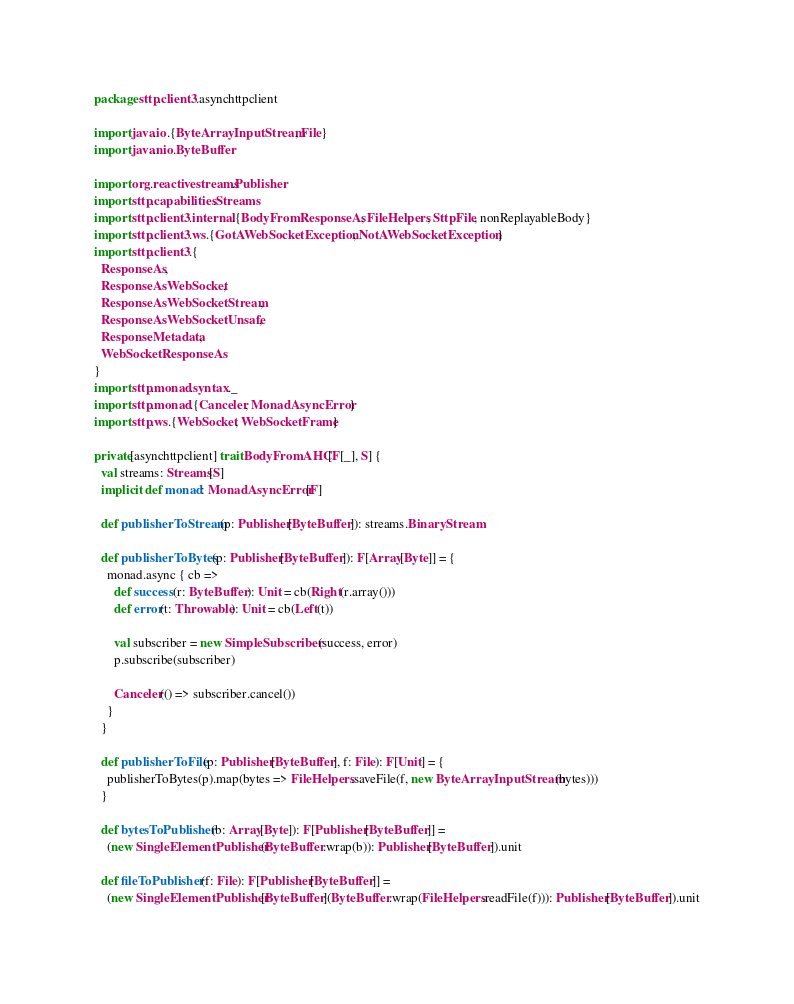Convert code to text. <code><loc_0><loc_0><loc_500><loc_500><_Scala_>package sttp.client3.asynchttpclient

import java.io.{ByteArrayInputStream, File}
import java.nio.ByteBuffer

import org.reactivestreams.Publisher
import sttp.capabilities.Streams
import sttp.client3.internal.{BodyFromResponseAs, FileHelpers, SttpFile, nonReplayableBody}
import sttp.client3.ws.{GotAWebSocketException, NotAWebSocketException}
import sttp.client3.{
  ResponseAs,
  ResponseAsWebSocket,
  ResponseAsWebSocketStream,
  ResponseAsWebSocketUnsafe,
  ResponseMetadata,
  WebSocketResponseAs
}
import sttp.monad.syntax._
import sttp.monad.{Canceler, MonadAsyncError}
import sttp.ws.{WebSocket, WebSocketFrame}

private[asynchttpclient] trait BodyFromAHC[F[_], S] {
  val streams: Streams[S]
  implicit def monad: MonadAsyncError[F]

  def publisherToStream(p: Publisher[ByteBuffer]): streams.BinaryStream

  def publisherToBytes(p: Publisher[ByteBuffer]): F[Array[Byte]] = {
    monad.async { cb =>
      def success(r: ByteBuffer): Unit = cb(Right(r.array()))
      def error(t: Throwable): Unit = cb(Left(t))

      val subscriber = new SimpleSubscriber(success, error)
      p.subscribe(subscriber)

      Canceler(() => subscriber.cancel())
    }
  }

  def publisherToFile(p: Publisher[ByteBuffer], f: File): F[Unit] = {
    publisherToBytes(p).map(bytes => FileHelpers.saveFile(f, new ByteArrayInputStream(bytes)))
  }

  def bytesToPublisher(b: Array[Byte]): F[Publisher[ByteBuffer]] =
    (new SingleElementPublisher(ByteBuffer.wrap(b)): Publisher[ByteBuffer]).unit

  def fileToPublisher(f: File): F[Publisher[ByteBuffer]] =
    (new SingleElementPublisher[ByteBuffer](ByteBuffer.wrap(FileHelpers.readFile(f))): Publisher[ByteBuffer]).unit
</code> 